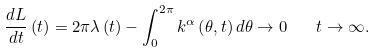<formula> <loc_0><loc_0><loc_500><loc_500>\frac { d L } { d t } \left ( t \right ) = 2 \pi \lambda \left ( t \right ) - \int _ { 0 } ^ { 2 \pi } k ^ { \alpha } \left ( \theta , t \right ) d \theta \rightarrow 0 \quad t \rightarrow \infty .</formula> 